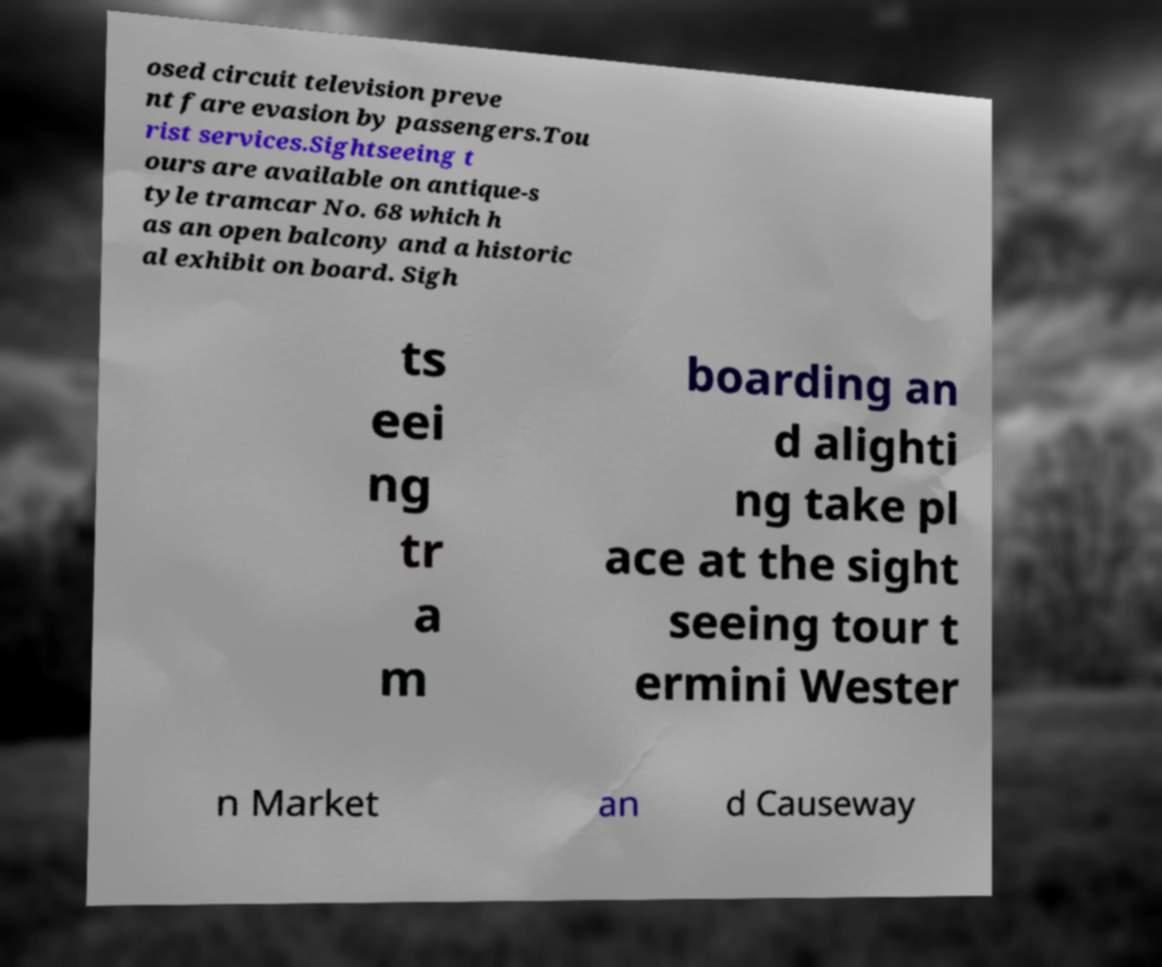Please identify and transcribe the text found in this image. osed circuit television preve nt fare evasion by passengers.Tou rist services.Sightseeing t ours are available on antique-s tyle tramcar No. 68 which h as an open balcony and a historic al exhibit on board. Sigh ts eei ng tr a m boarding an d alighti ng take pl ace at the sight seeing tour t ermini Wester n Market an d Causeway 